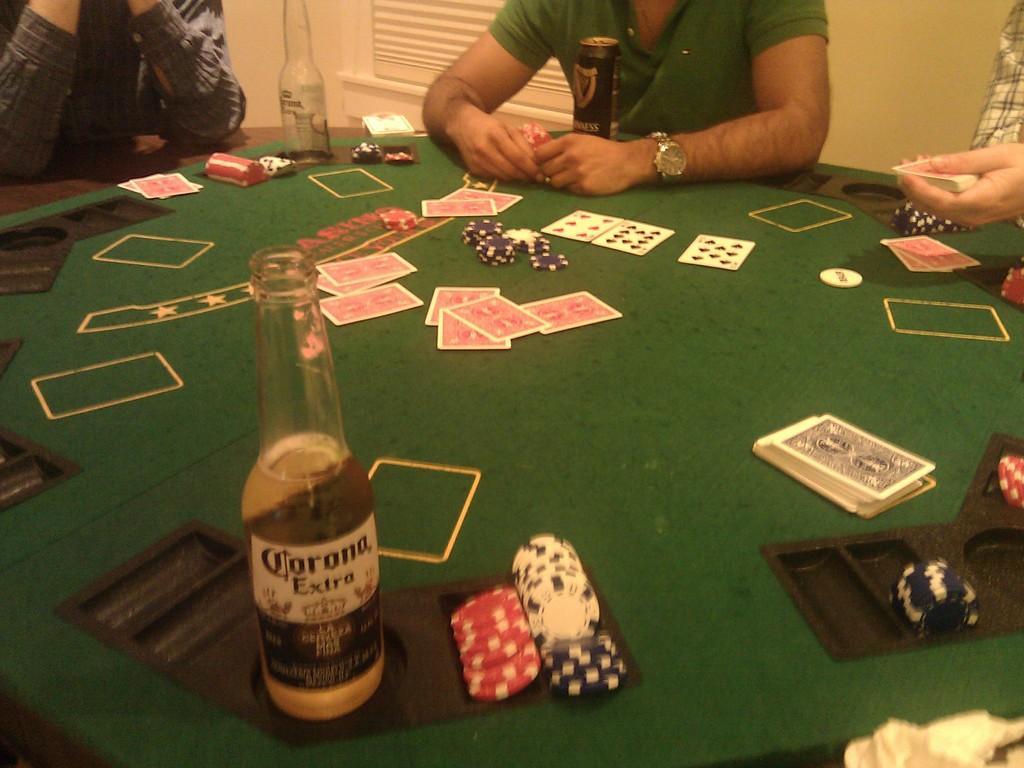Could you give a brief overview of what you see in this image? In this image I can see a cards,coins,wine-bottle and some objects on the green color table. I can see few person sitting around. The wall is in cream color. 